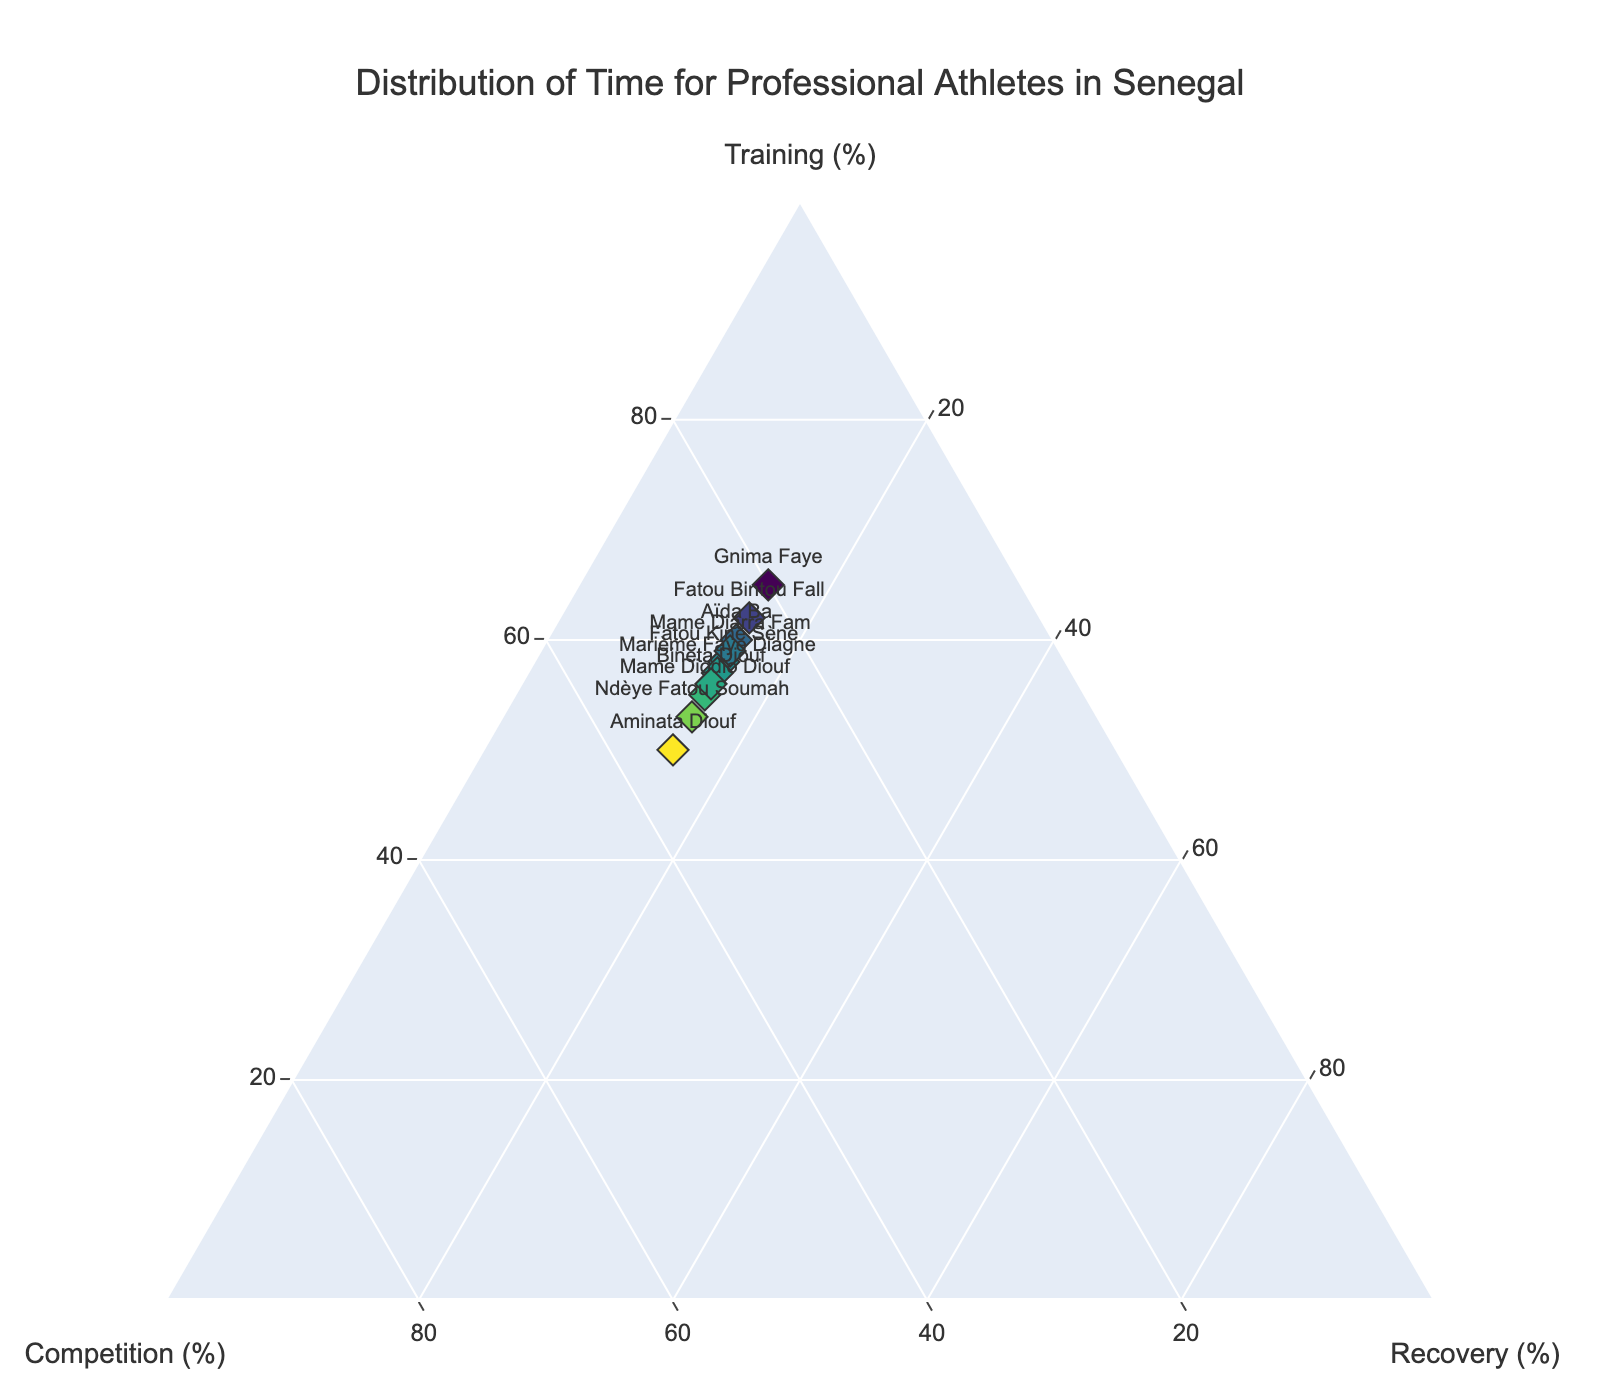How many athletes are displayed in the plot? We can count the number of distinct data points displayed for the athletes in the ternary plot. Each point represents one athlete.
Answer: 10 What is the title of the plot? The title is usually located at the top of the plot and provides a brief description of the data being visualized.
Answer: Distribution of Time for Professional Athletes in Senegal Which athlete dedicates the most time to training? By looking at the axis labeled "Training (%)", identify the data point that is closest to the high end of this axis.
Answer: Gnima Faye Are there any athletes who spend equal time on competition? By examining the "Competition (%)" axis, look for data points that share the same value (e.g., 15%).
Answer: Yes, Aïda Ba, Mame Diodio Diouf, Gnima Faye, Aminata Diouf, Fatou Kiné Sène, Fatou Bintou Fall, Marième Faye Diagne, Mame Diarra Fam, and Bineta Diouf Which group of activities (Training, Competition, Recovery) is fixed for all athletes? By scanning through the plot, notice if any axis has the same value for all data points.
Answer: Recovery (15%) Which athlete spends the least time on competition? Looking at the lower end of the "Competition (%)" axis, identify the point located nearest to this end.
Answer: Gnima Faye How many athletes spend more than 60% of their time on training? Identify data points where the percentage on the "Training (%)" axis is greater than 60%. Count these data points.
Answer: 3 If an athlete increases their training time by 5% and reduces their competition time by 5%, how would the change visually appear on the plot? This would shift the data point towards the "Training (%)" axis and away from the "Competition (%)" axis. The point will move diagonally, keeping the total percentage sum constant.
Answer: Shifted diagonally towards "Training (%)" Who is closer to spending equal time across all three activities, Aïda Ba or Aminata Diouf? Calculate the absolute differences from the average (33.33%) for both athletes across Training, Competition, and Recovery, then compare these sums to determine who is closer.
Answer: Aminata Diouf 